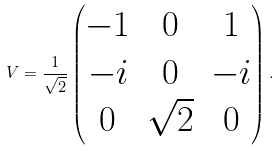<formula> <loc_0><loc_0><loc_500><loc_500>V = \frac { 1 } { \sqrt { 2 } } \begin{pmatrix} - 1 & 0 & 1 \\ - i & 0 & - i \\ 0 & \sqrt { 2 } & 0 \end{pmatrix} .</formula> 